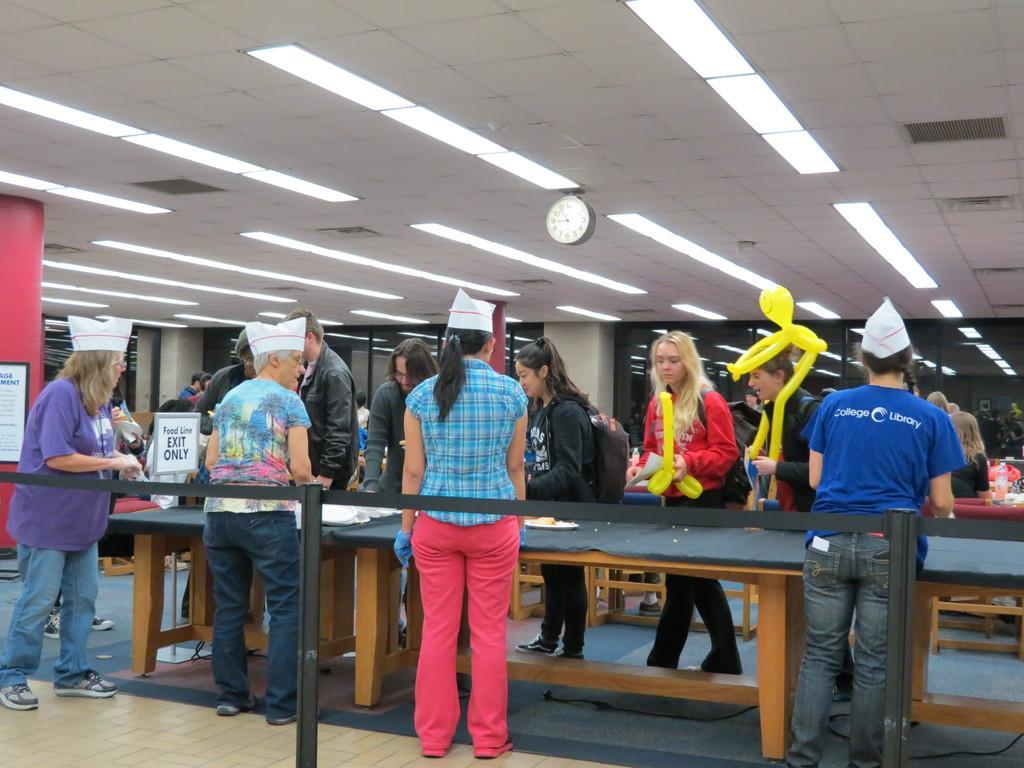Describe this image in one or two sentences. In this picture there are group of people standing at the table. There are objects on the table. In the foreground there is a railing. At the back there are pillars. At the top there are lights and there is a clock. 